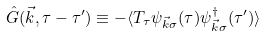<formula> <loc_0><loc_0><loc_500><loc_500>\hat { G } ( \vec { k } , \tau - \tau ^ { \prime } ) \equiv - \langle T _ { \tau } \psi _ { \vec { k } \sigma } ( \tau ) \psi ^ { \dagger } _ { \vec { k } \sigma } ( \tau ^ { \prime } ) \rangle</formula> 